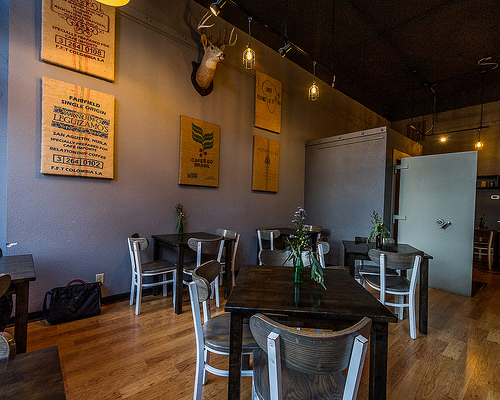<image>
Is the vase on the table? No. The vase is not positioned on the table. They may be near each other, but the vase is not supported by or resting on top of the table. 